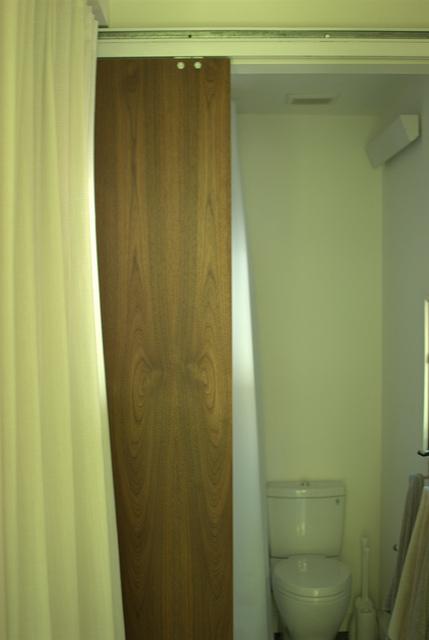Is there toilet paper?
Concise answer only. No. What is the door made of?
Write a very short answer. Wood. What color is the toilet?
Answer briefly. White. Who is in the bathroom?
Short answer required. No one. 